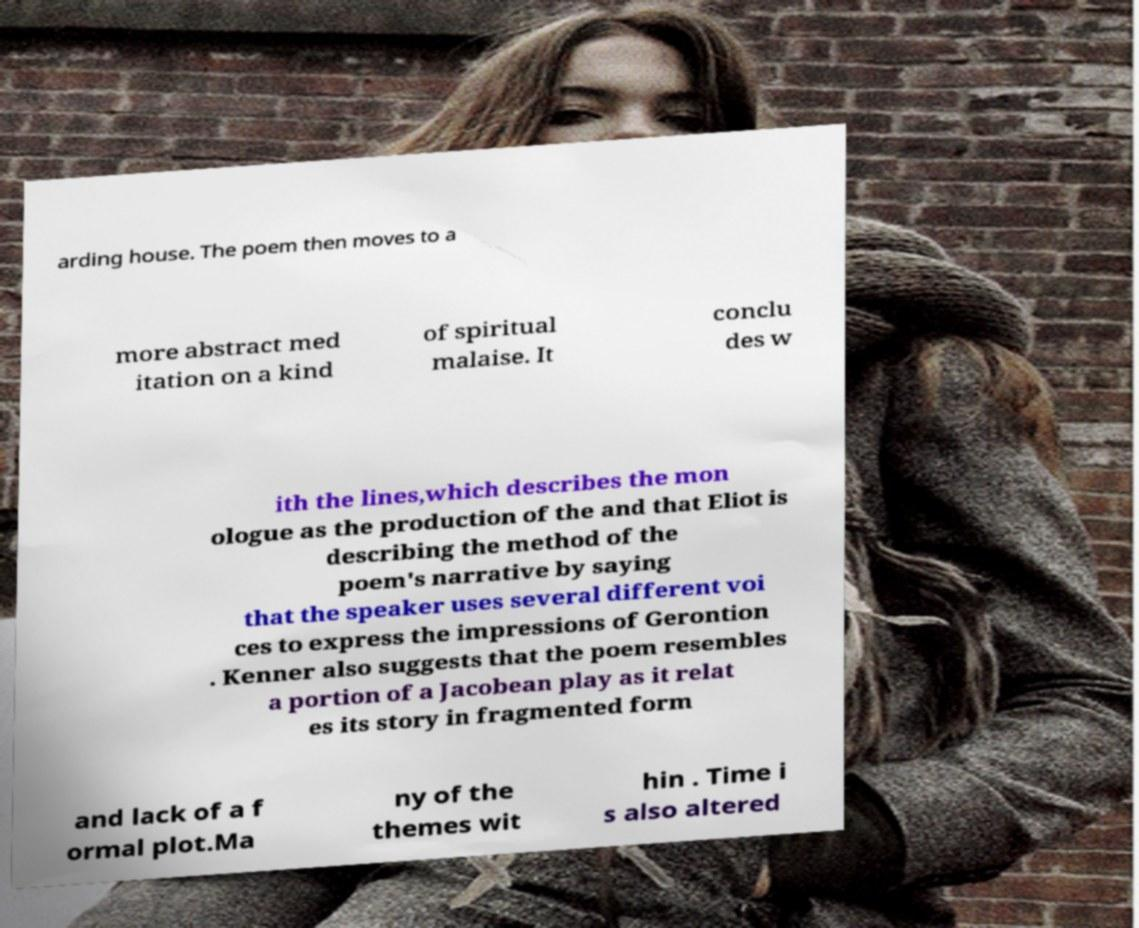Can you accurately transcribe the text from the provided image for me? arding house. The poem then moves to a more abstract med itation on a kind of spiritual malaise. It conclu des w ith the lines,which describes the mon ologue as the production of the and that Eliot is describing the method of the poem's narrative by saying that the speaker uses several different voi ces to express the impressions of Gerontion . Kenner also suggests that the poem resembles a portion of a Jacobean play as it relat es its story in fragmented form and lack of a f ormal plot.Ma ny of the themes wit hin . Time i s also altered 